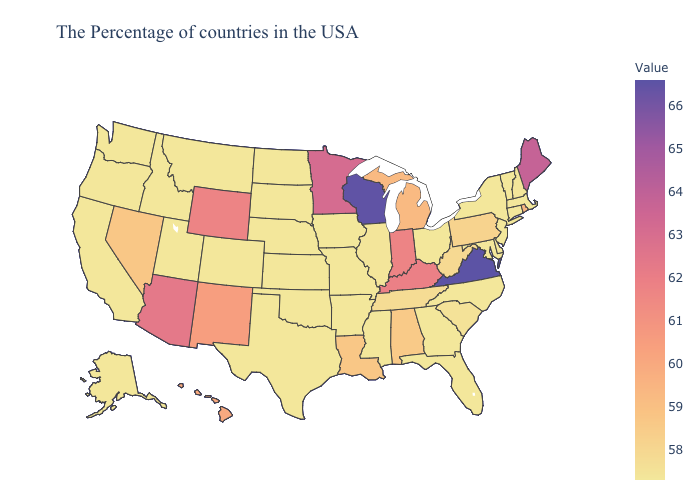Among the states that border Wisconsin , does Illinois have the highest value?
Quick response, please. No. Which states have the highest value in the USA?
Write a very short answer. Virginia. Does North Carolina have the highest value in the USA?
Short answer required. No. 